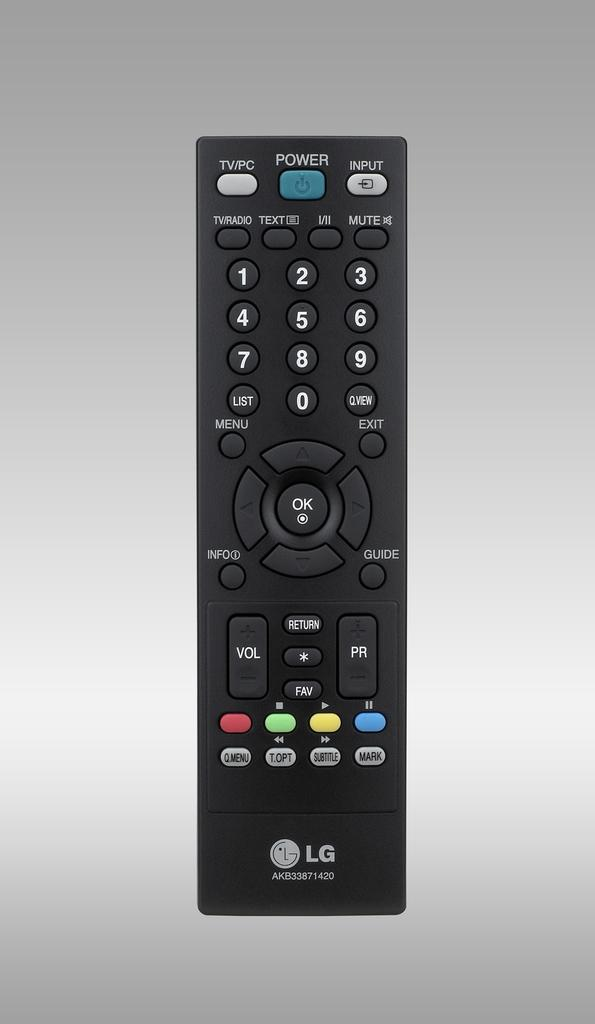<image>
Summarize the visual content of the image. An LG remote control with a blue Power button at the top. 